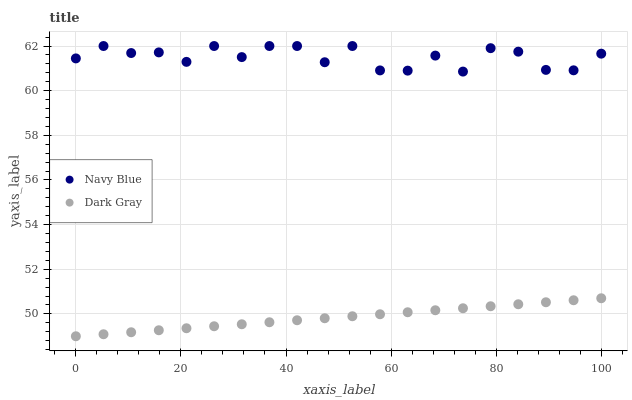Does Dark Gray have the minimum area under the curve?
Answer yes or no. Yes. Does Navy Blue have the maximum area under the curve?
Answer yes or no. Yes. Does Navy Blue have the minimum area under the curve?
Answer yes or no. No. Is Dark Gray the smoothest?
Answer yes or no. Yes. Is Navy Blue the roughest?
Answer yes or no. Yes. Is Navy Blue the smoothest?
Answer yes or no. No. Does Dark Gray have the lowest value?
Answer yes or no. Yes. Does Navy Blue have the lowest value?
Answer yes or no. No. Does Navy Blue have the highest value?
Answer yes or no. Yes. Is Dark Gray less than Navy Blue?
Answer yes or no. Yes. Is Navy Blue greater than Dark Gray?
Answer yes or no. Yes. Does Dark Gray intersect Navy Blue?
Answer yes or no. No. 